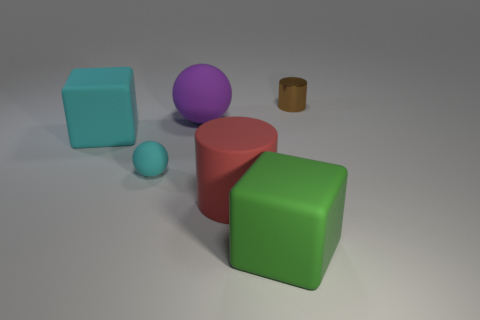What number of objects are cyan cubes in front of the large sphere or gray shiny blocks?
Make the answer very short. 1. Is there anything else that is the same material as the big green object?
Ensure brevity in your answer.  Yes. What number of things are both behind the big green object and left of the brown shiny object?
Ensure brevity in your answer.  4. How many things are either things that are on the left side of the small cylinder or large matte things behind the green rubber object?
Provide a succinct answer. 5. Do the small object on the left side of the tiny cylinder and the tiny cylinder have the same color?
Offer a very short reply. No. How many other objects are there of the same size as the green thing?
Your response must be concise. 3. Do the small ball and the big red object have the same material?
Make the answer very short. Yes. There is a ball that is behind the big matte block that is on the left side of the small cyan matte sphere; what color is it?
Offer a terse response. Purple. There is a green thing that is the same shape as the big cyan thing; what is its size?
Give a very brief answer. Large. Does the shiny thing have the same color as the large sphere?
Your response must be concise. No. 